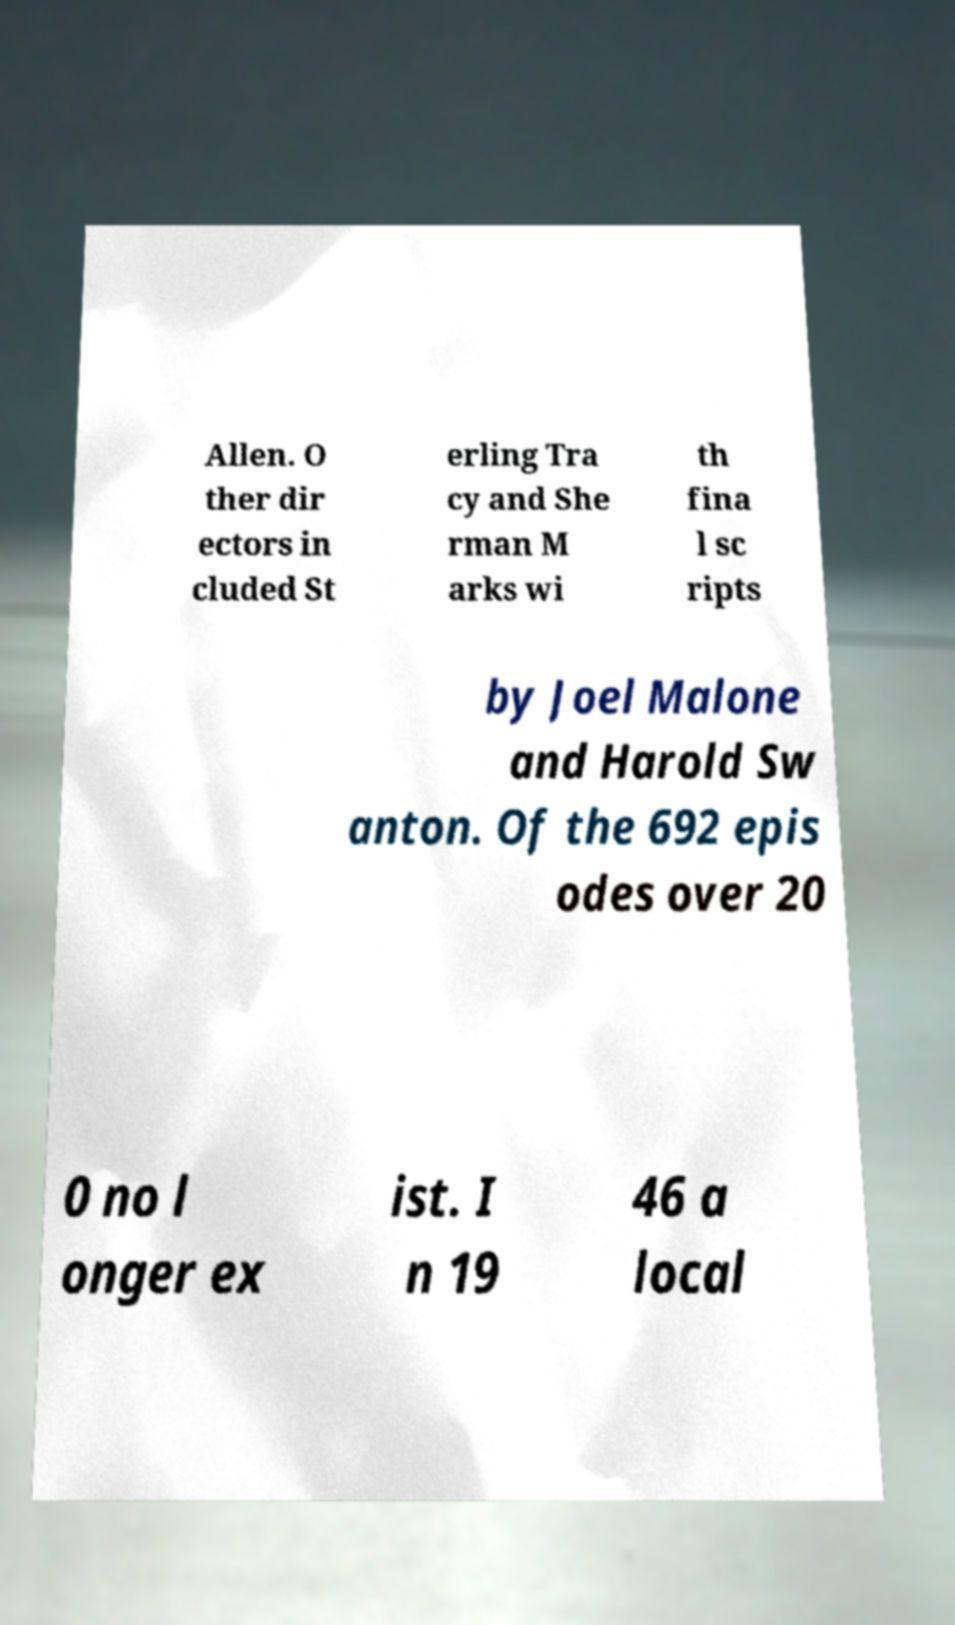Please read and relay the text visible in this image. What does it say? Allen. O ther dir ectors in cluded St erling Tra cy and She rman M arks wi th fina l sc ripts by Joel Malone and Harold Sw anton. Of the 692 epis odes over 20 0 no l onger ex ist. I n 19 46 a local 